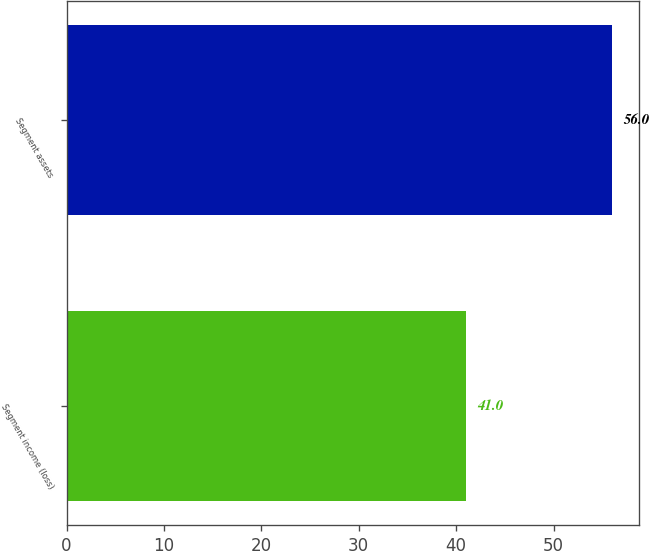Convert chart. <chart><loc_0><loc_0><loc_500><loc_500><bar_chart><fcel>Segment income (loss)<fcel>Segment assets<nl><fcel>41<fcel>56<nl></chart> 